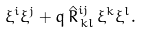Convert formula to latex. <formula><loc_0><loc_0><loc_500><loc_500>\xi ^ { i } \xi ^ { j } + q \, { \hat { R } } ^ { i j } _ { \, k l } \, \xi ^ { k } \xi ^ { l } .</formula> 